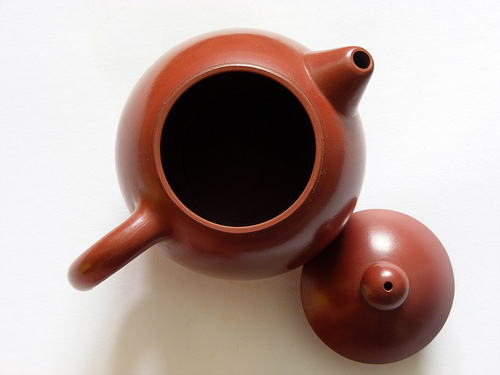<image>
Is the pot on the cap? No. The pot is not positioned on the cap. They may be near each other, but the pot is not supported by or resting on top of the cap. 